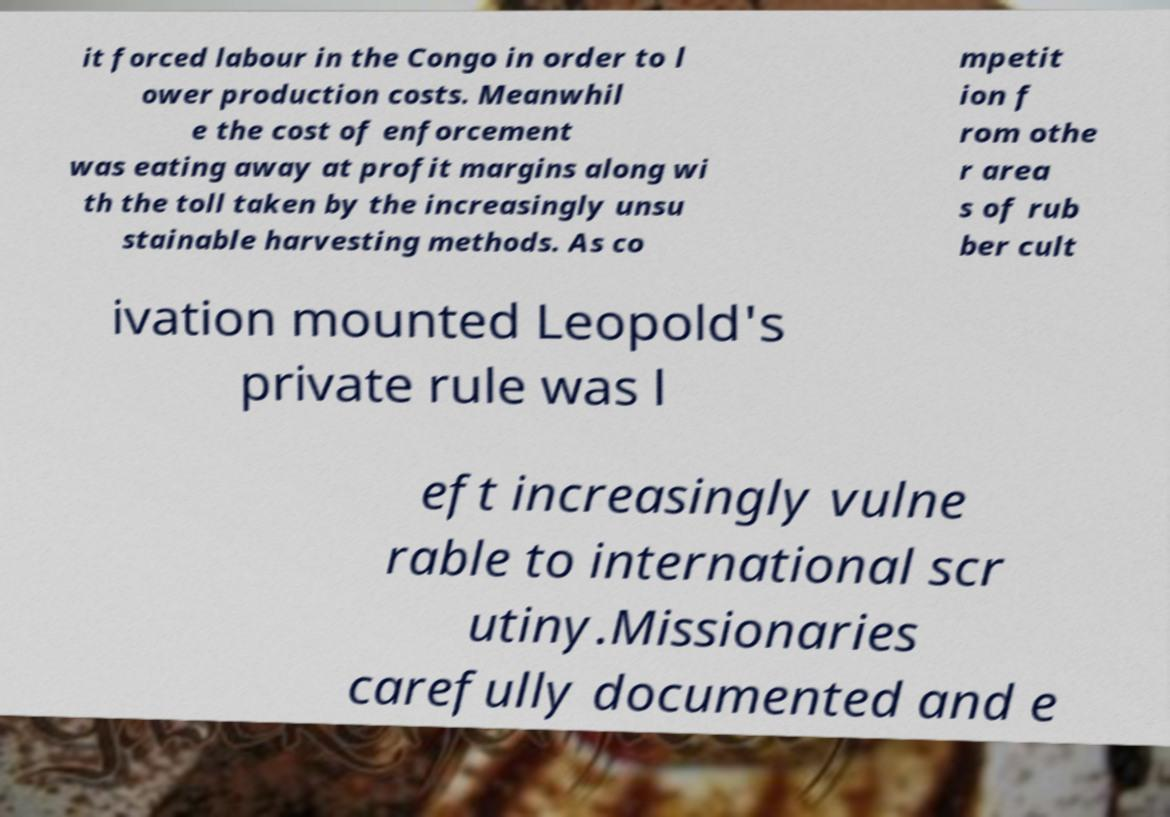What messages or text are displayed in this image? I need them in a readable, typed format. it forced labour in the Congo in order to l ower production costs. Meanwhil e the cost of enforcement was eating away at profit margins along wi th the toll taken by the increasingly unsu stainable harvesting methods. As co mpetit ion f rom othe r area s of rub ber cult ivation mounted Leopold's private rule was l eft increasingly vulne rable to international scr utiny.Missionaries carefully documented and e 